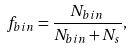Convert formula to latex. <formula><loc_0><loc_0><loc_500><loc_500>f _ { b i n } = \frac { N _ { b i n } } { N _ { b i n } + N _ { s } } ,</formula> 